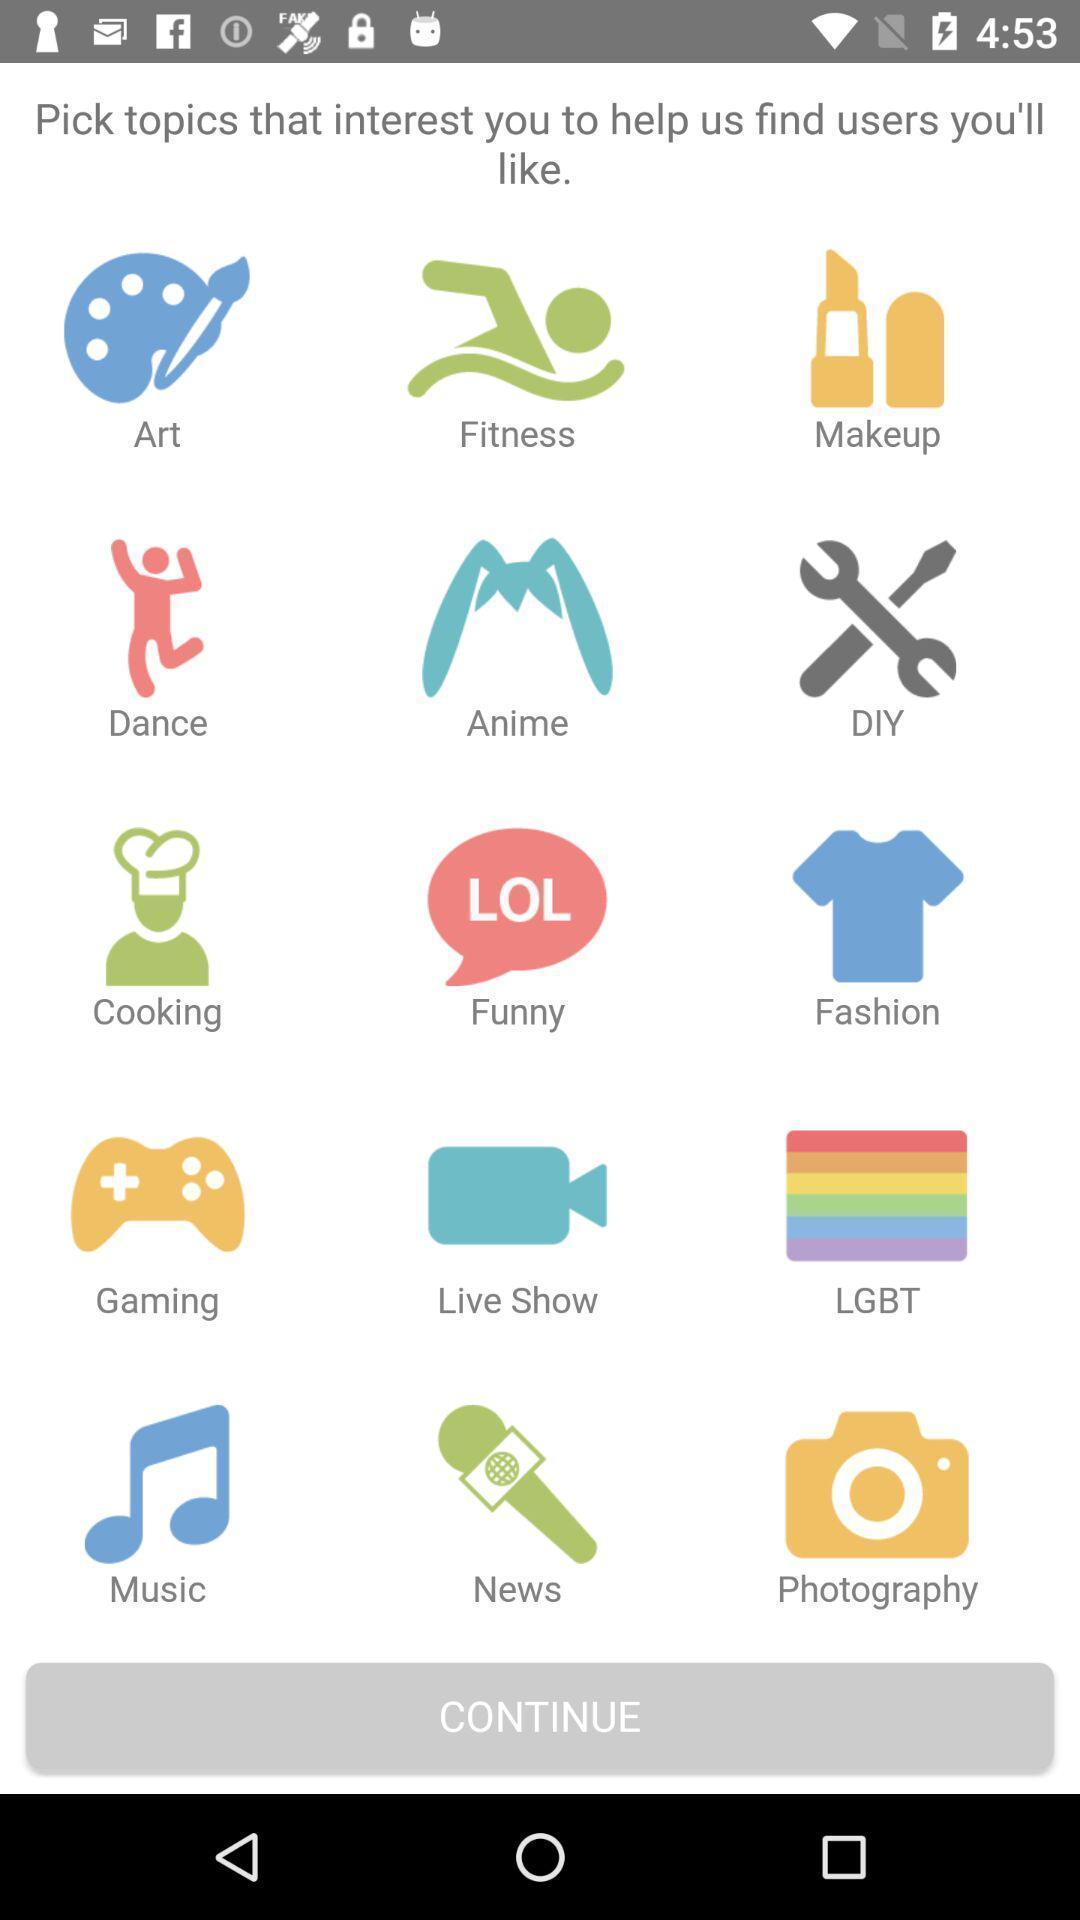Give me a summary of this screen capture. Welcome page. 